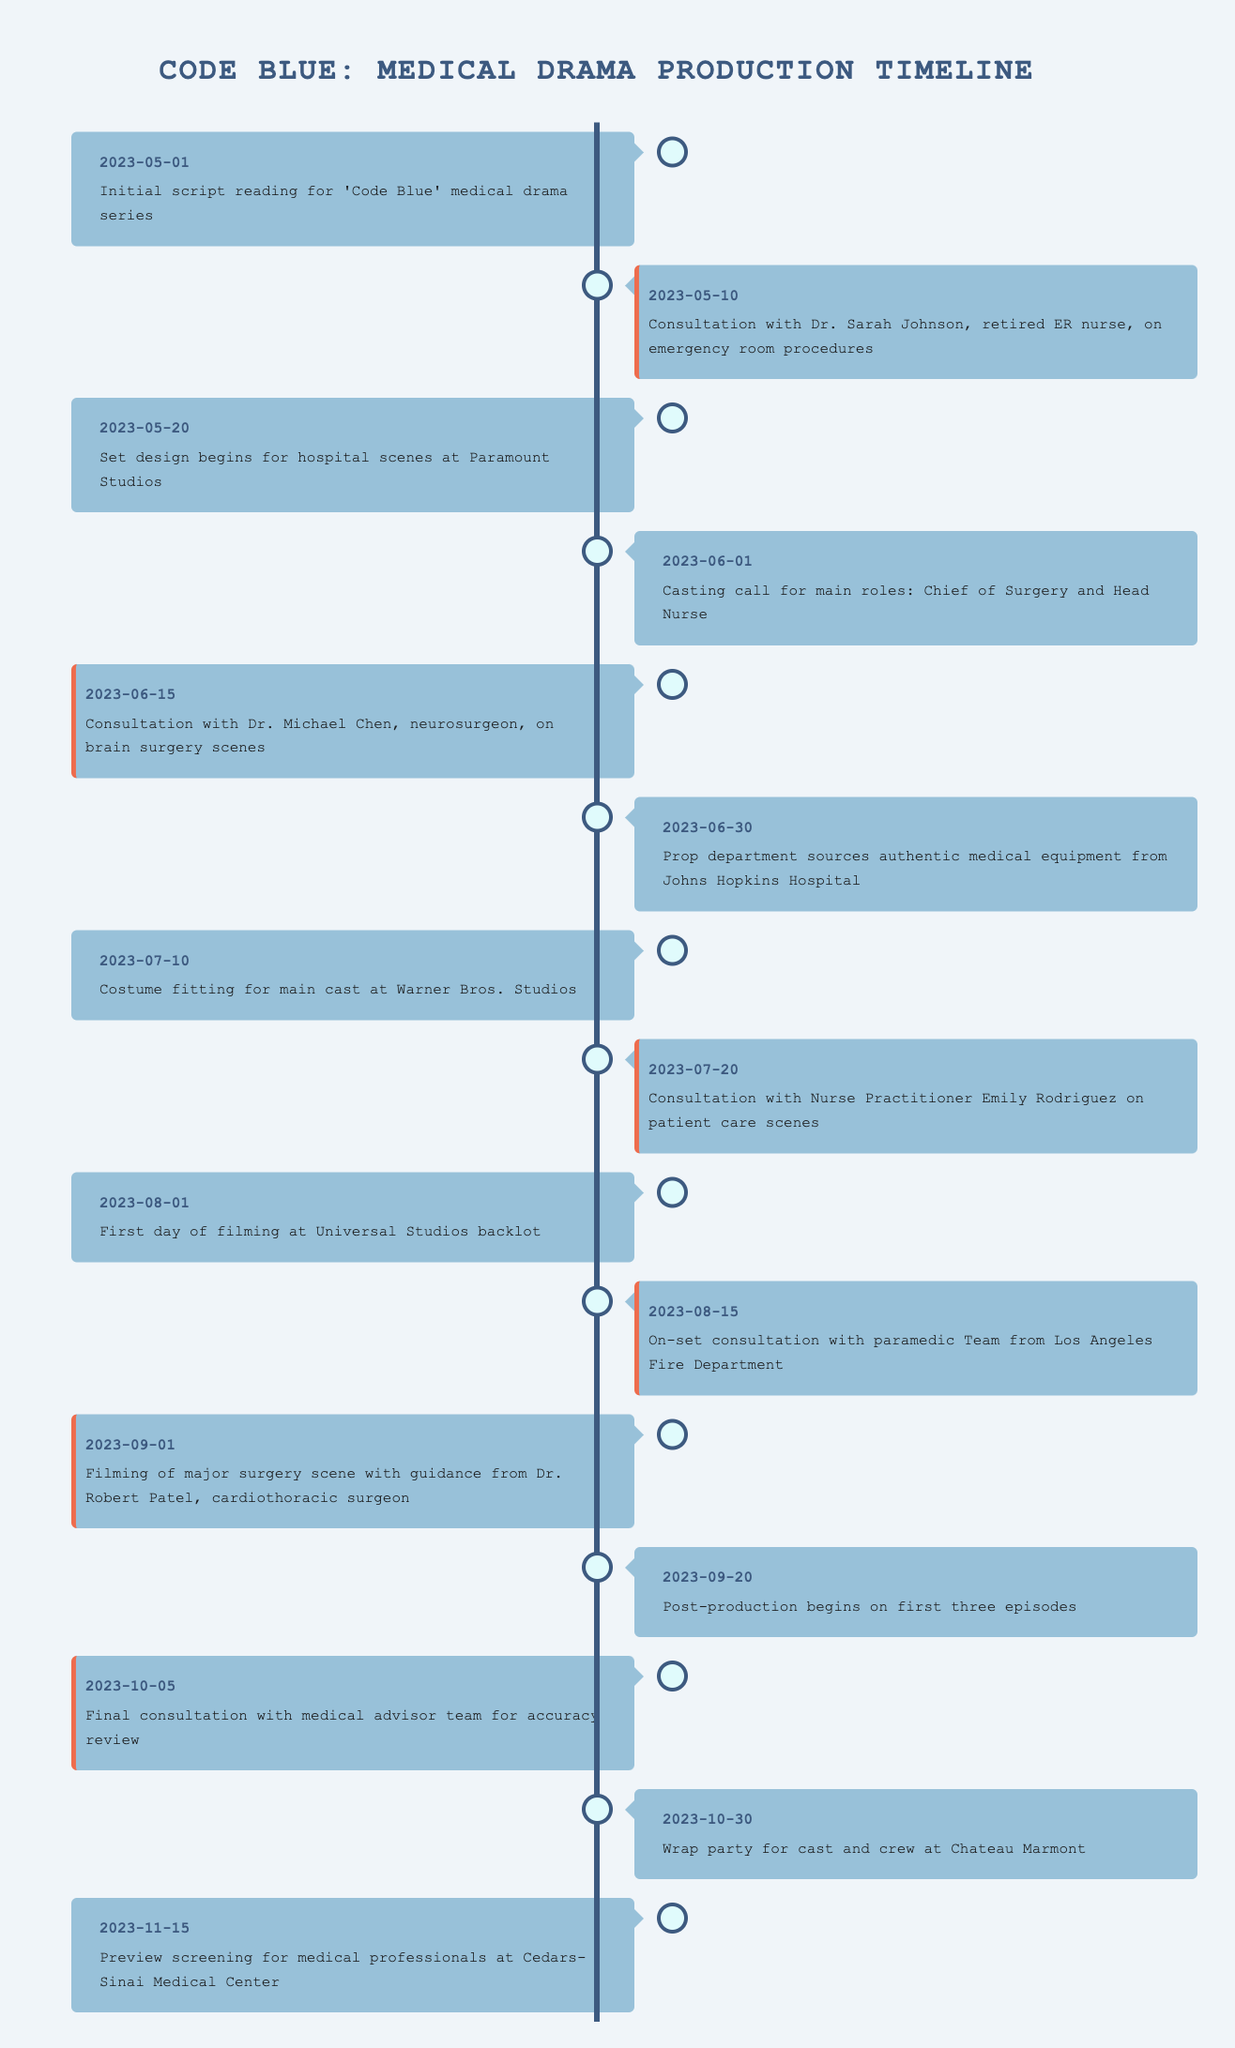What was the first event in the timeline? The first event listed in the table is "Initial script reading for 'Code Blue' medical drama series" on the date 2023-05-01.
Answer: Initial script reading for 'Code Blue' medical drama series How many consultation sessions are scheduled before filming begins? From the timeline, the consultation sessions are on 2023-05-10, 2023-06-15, 2023-07-20, 2023-08-15, and 2023-10-05. This totals to five consultation sessions before filming starts on 2023-08-01.
Answer: 5 What is the date of the final consultation with the medical advisor team? The last consultation event listed is on 2023-10-05, as stated in the timeline.
Answer: 2023-10-05 Did the series have consultations with both a retired nurse and a nurse practitioner? Yes, the timeline shows a consultation with Dr. Sarah Johnson, a retired ER nurse, and another with Nurse Practitioner Emily Rodriguez.
Answer: Yes What event immediately precedes the wrap party? The wrap party at Chateau Marmont on 2023-10-30 is preceded by the final consultation on 2023-10-05 and the first three episodes' post-production starting on 2023-09-20.
Answer: Final consultation on 2023-10-05 What was the time gap between the start of filming and the first consultation regarding brain surgery? The first day of filming is on 2023-08-01, and consultation for brain surgery occurred on 2023-06-15. The time gap between these two dates is 47 days.
Answer: 47 days How many days are there from the initial script reading to the first day of filming? The initial script reading was on 2023-05-01 and filming began on 2023-08-01. The total number of days between these dates can be calculated as 92 days.
Answer: 92 days Which medical professional was consulted for the major surgery scene? The timeline states that Dr. Robert Patel, a cardiothoracic surgeon, was consulted for guidance on the major surgery scene on 2023-09-01.
Answer: Dr. Robert Patel What are the dates of the set design and the first day of filming? The set design began on 2023-05-20 and the first day of filming occurred on 2023-08-01. These dates show the project's progression over time.
Answer: 2023-05-20 and 2023-08-01 